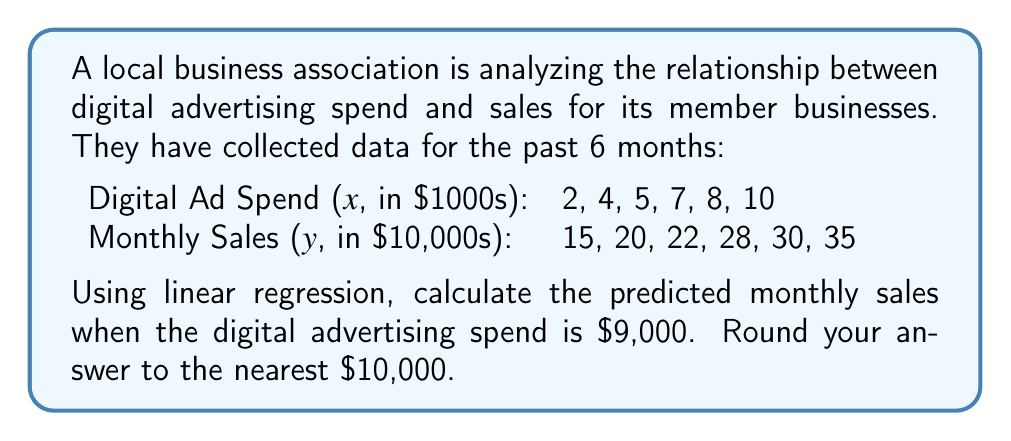Give your solution to this math problem. To solve this problem, we'll use the linear regression formula:

$$y = mx + b$$

Where $m$ is the slope and $b$ is the y-intercept.

Step 1: Calculate the slope $(m)$
$$m = \frac{n\sum xy - \sum x \sum y}{n\sum x^2 - (\sum x)^2}$$

Where $n$ is the number of data points (6 in this case).

First, let's calculate the necessary sums:
$\sum x = 36$
$\sum y = 150$
$\sum xy = 830$
$\sum x^2 = 262$

Now, let's plug these into the slope formula:

$$m = \frac{6(830) - (36)(150)}{6(262) - (36)^2} = \frac{4980 - 5400}{1572 - 1296} = \frac{-420}{276} = -1.52173913$$

Step 2: Calculate the y-intercept $(b)$
$$b = \bar{y} - m\bar{x}$$

Where $\bar{x}$ and $\bar{y}$ are the means of $x$ and $y$ respectively.

$\bar{x} = \frac{36}{6} = 6$
$\bar{y} = \frac{150}{6} = 25$

$$b = 25 - (-1.52173913)(6) = 34.1304348$$

Step 3: Form the linear regression equation
$$y = -1.52173913x + 34.1304348$$

Step 4: Predict sales for $9,000 in ad spend (x = 9)
$$y = -1.52173913(9) + 34.1304348 = 32.4347825$$

Step 5: Convert back to original units and round
$32.4347825 * 10,000 = 324,347.83$

Rounding to the nearest $10,000: $320,000
Answer: $320,000 